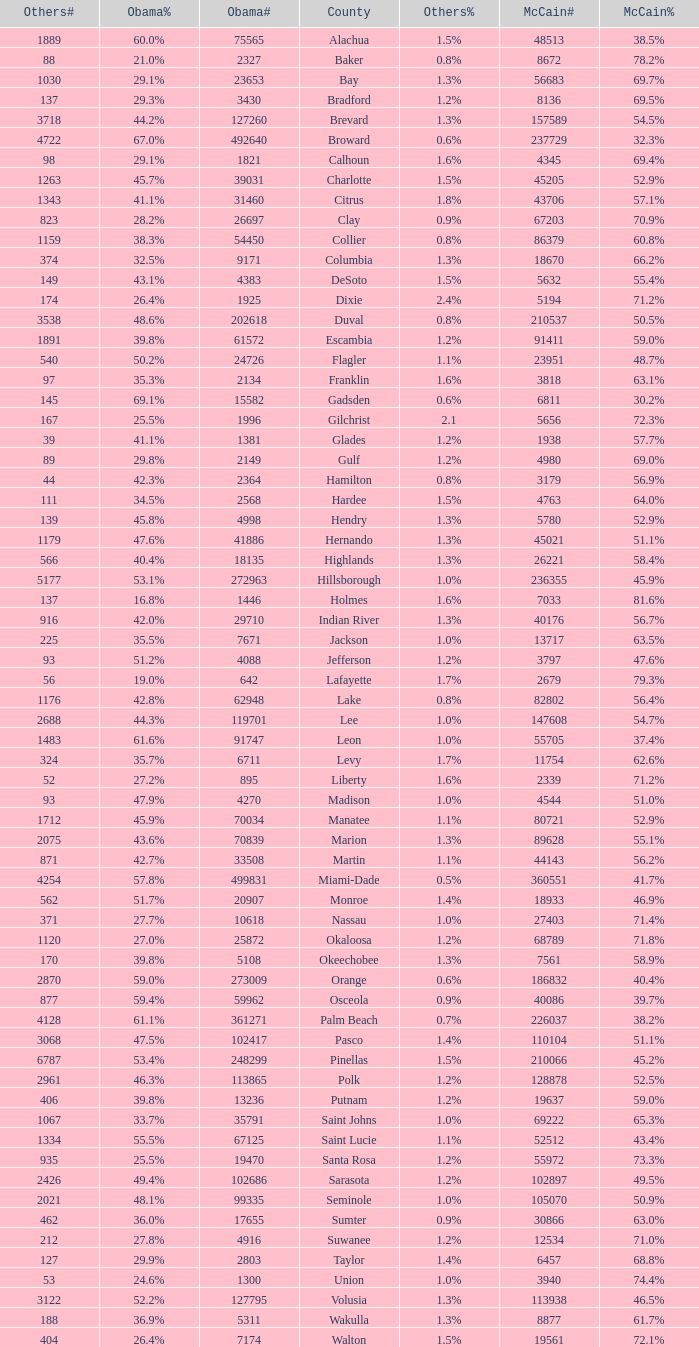How many numbers were recorded under Obama when he had 29.9% voters? 1.0. 